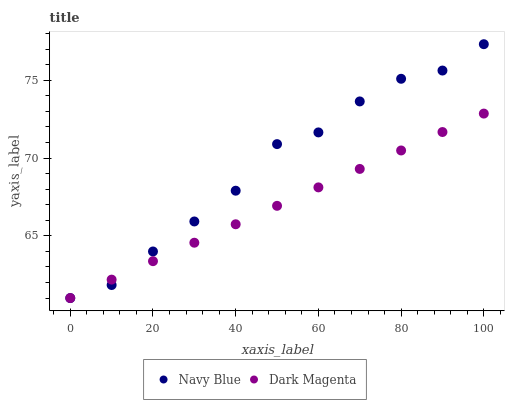Does Dark Magenta have the minimum area under the curve?
Answer yes or no. Yes. Does Navy Blue have the maximum area under the curve?
Answer yes or no. Yes. Does Dark Magenta have the maximum area under the curve?
Answer yes or no. No. Is Dark Magenta the smoothest?
Answer yes or no. Yes. Is Navy Blue the roughest?
Answer yes or no. Yes. Is Dark Magenta the roughest?
Answer yes or no. No. Does Navy Blue have the lowest value?
Answer yes or no. Yes. Does Navy Blue have the highest value?
Answer yes or no. Yes. Does Dark Magenta have the highest value?
Answer yes or no. No. Does Dark Magenta intersect Navy Blue?
Answer yes or no. Yes. Is Dark Magenta less than Navy Blue?
Answer yes or no. No. Is Dark Magenta greater than Navy Blue?
Answer yes or no. No. 